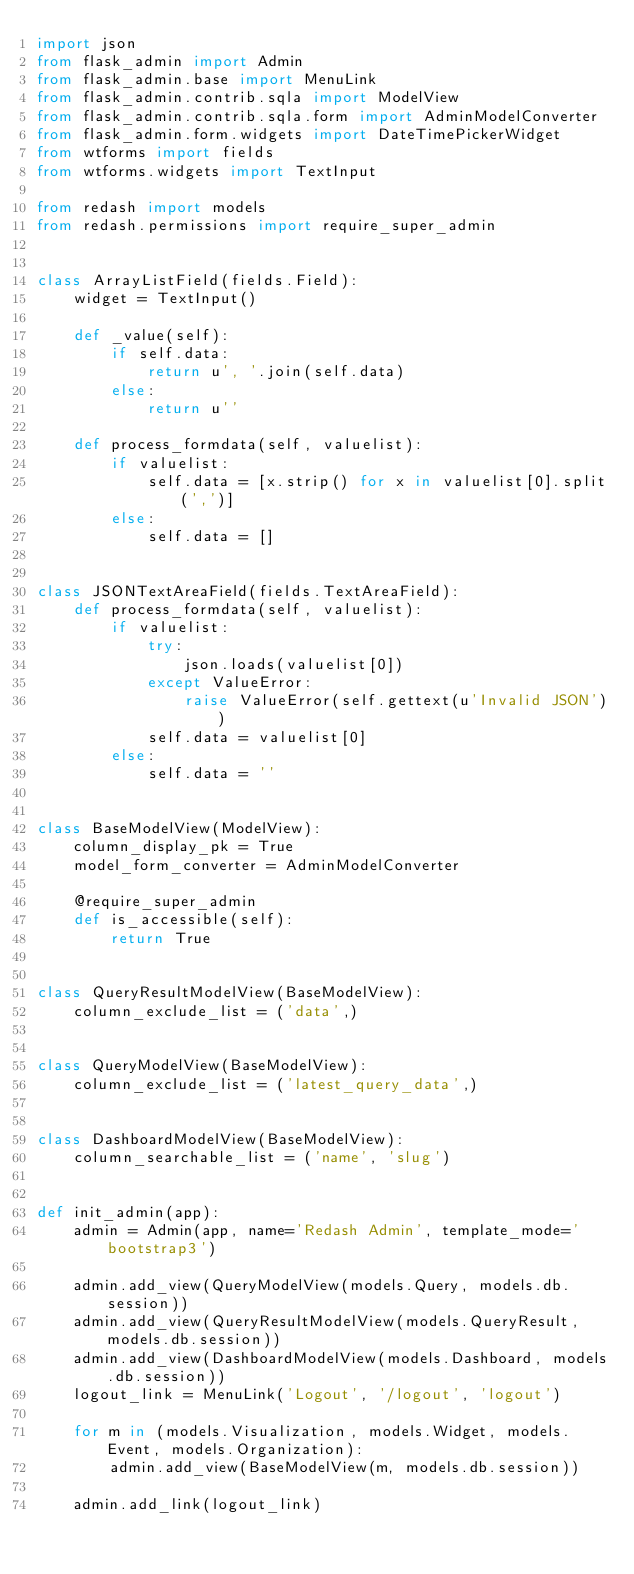Convert code to text. <code><loc_0><loc_0><loc_500><loc_500><_Python_>import json
from flask_admin import Admin
from flask_admin.base import MenuLink
from flask_admin.contrib.sqla import ModelView
from flask_admin.contrib.sqla.form import AdminModelConverter
from flask_admin.form.widgets import DateTimePickerWidget
from wtforms import fields
from wtforms.widgets import TextInput

from redash import models
from redash.permissions import require_super_admin


class ArrayListField(fields.Field):
    widget = TextInput()

    def _value(self):
        if self.data:
            return u', '.join(self.data)
        else:
            return u''

    def process_formdata(self, valuelist):
        if valuelist:
            self.data = [x.strip() for x in valuelist[0].split(',')]
        else:
            self.data = []


class JSONTextAreaField(fields.TextAreaField):
    def process_formdata(self, valuelist):
        if valuelist:
            try:
                json.loads(valuelist[0])
            except ValueError:
                raise ValueError(self.gettext(u'Invalid JSON'))
            self.data = valuelist[0]
        else:
            self.data = ''


class BaseModelView(ModelView):
    column_display_pk = True
    model_form_converter = AdminModelConverter

    @require_super_admin
    def is_accessible(self):
        return True


class QueryResultModelView(BaseModelView):
    column_exclude_list = ('data',)


class QueryModelView(BaseModelView):
    column_exclude_list = ('latest_query_data',)


class DashboardModelView(BaseModelView):
    column_searchable_list = ('name', 'slug')


def init_admin(app):
    admin = Admin(app, name='Redash Admin', template_mode='bootstrap3')

    admin.add_view(QueryModelView(models.Query, models.db.session))
    admin.add_view(QueryResultModelView(models.QueryResult, models.db.session))
    admin.add_view(DashboardModelView(models.Dashboard, models.db.session))
    logout_link = MenuLink('Logout', '/logout', 'logout')

    for m in (models.Visualization, models.Widget, models.Event, models.Organization):
        admin.add_view(BaseModelView(m, models.db.session))

    admin.add_link(logout_link)
</code> 